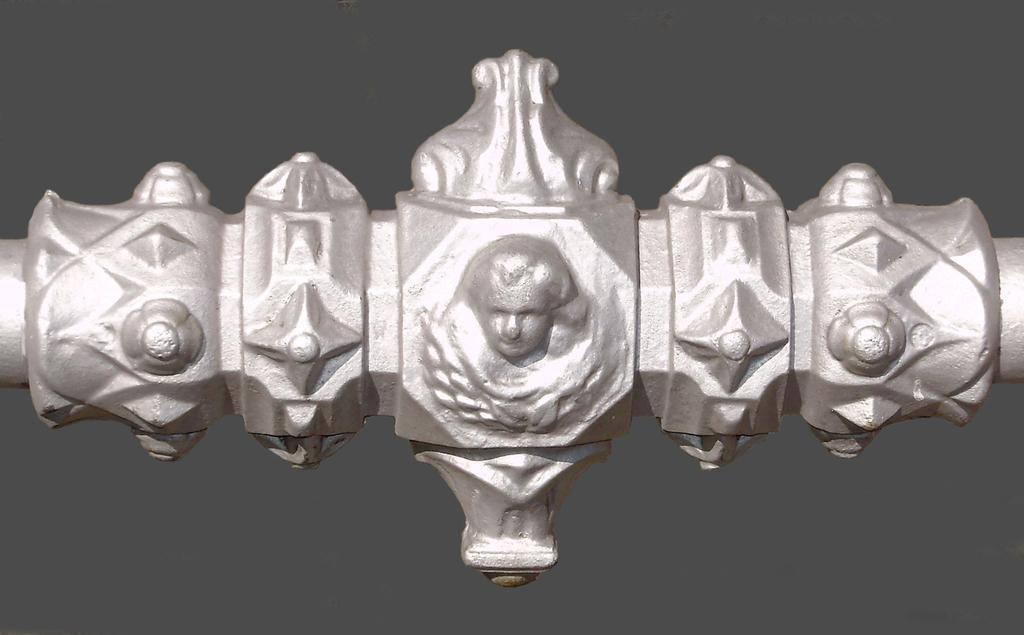Describe this image in one or two sentences. In this image we can see an object and in the center of the object we can see some persons structure. 